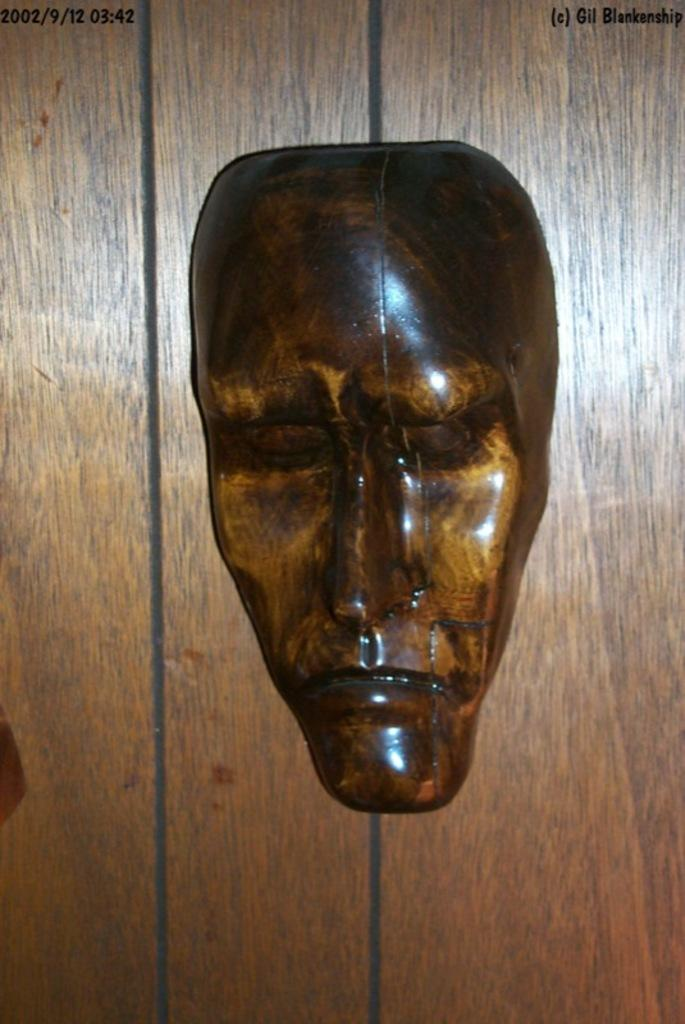What type of object is featured in the image? There is a wooden sculpture in the image. Where is the wooden sculpture located? The wooden sculpture is on a wall. What nation is depicted in the wooden sculpture? The wooden sculpture does not depict a nation; it is a sculpture made of wood. 